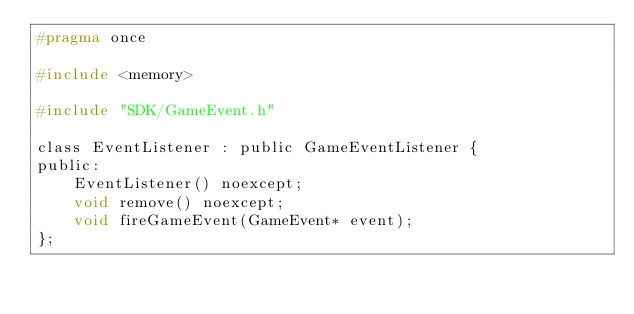<code> <loc_0><loc_0><loc_500><loc_500><_C_>#pragma once

#include <memory>

#include "SDK/GameEvent.h"

class EventListener : public GameEventListener {
public:
    EventListener() noexcept;
    void remove() noexcept;
    void fireGameEvent(GameEvent* event);
};
</code> 